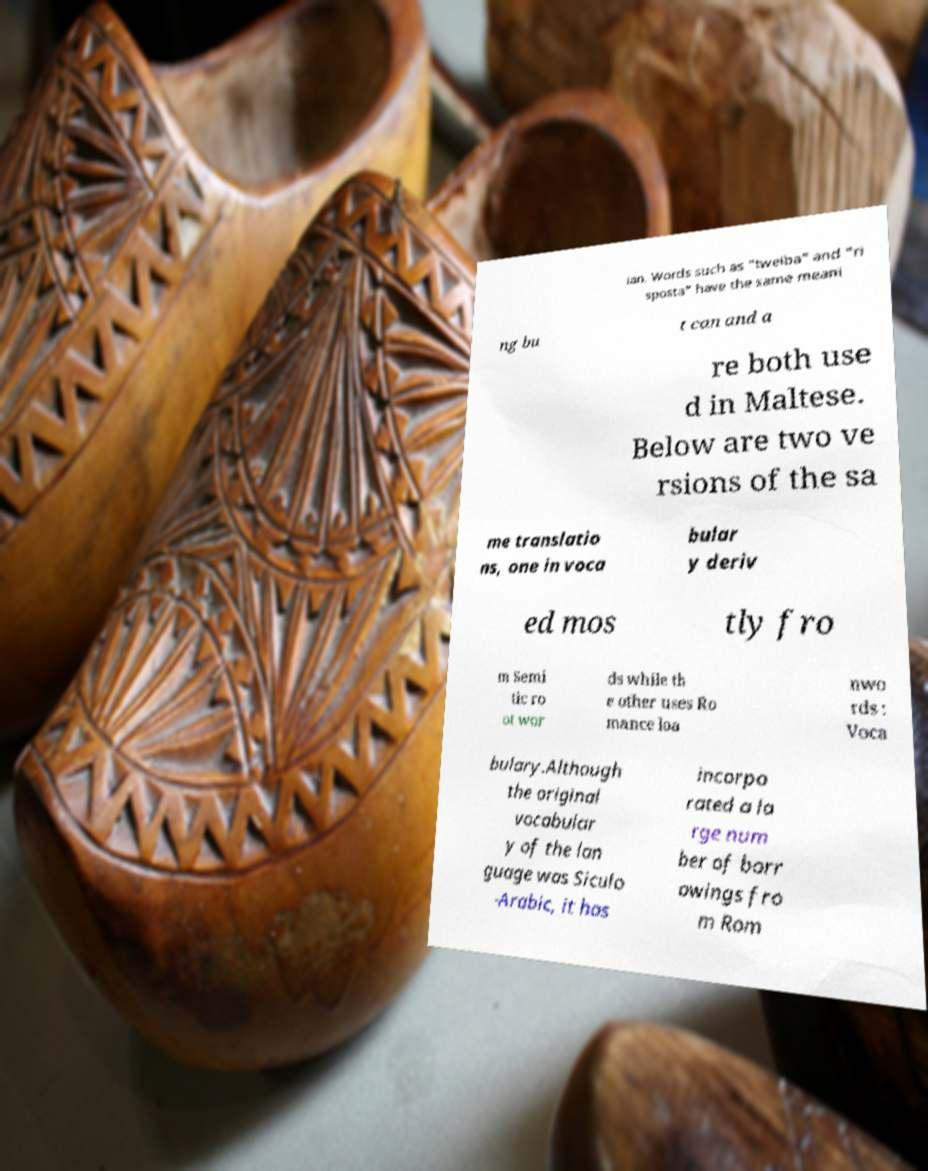Could you assist in decoding the text presented in this image and type it out clearly? ian. Words such as "tweiba" and "ri sposta" have the same meani ng bu t can and a re both use d in Maltese. Below are two ve rsions of the sa me translatio ns, one in voca bular y deriv ed mos tly fro m Semi tic ro ot wor ds while th e other uses Ro mance loa nwo rds : Voca bulary.Although the original vocabular y of the lan guage was Siculo -Arabic, it has incorpo rated a la rge num ber of borr owings fro m Rom 